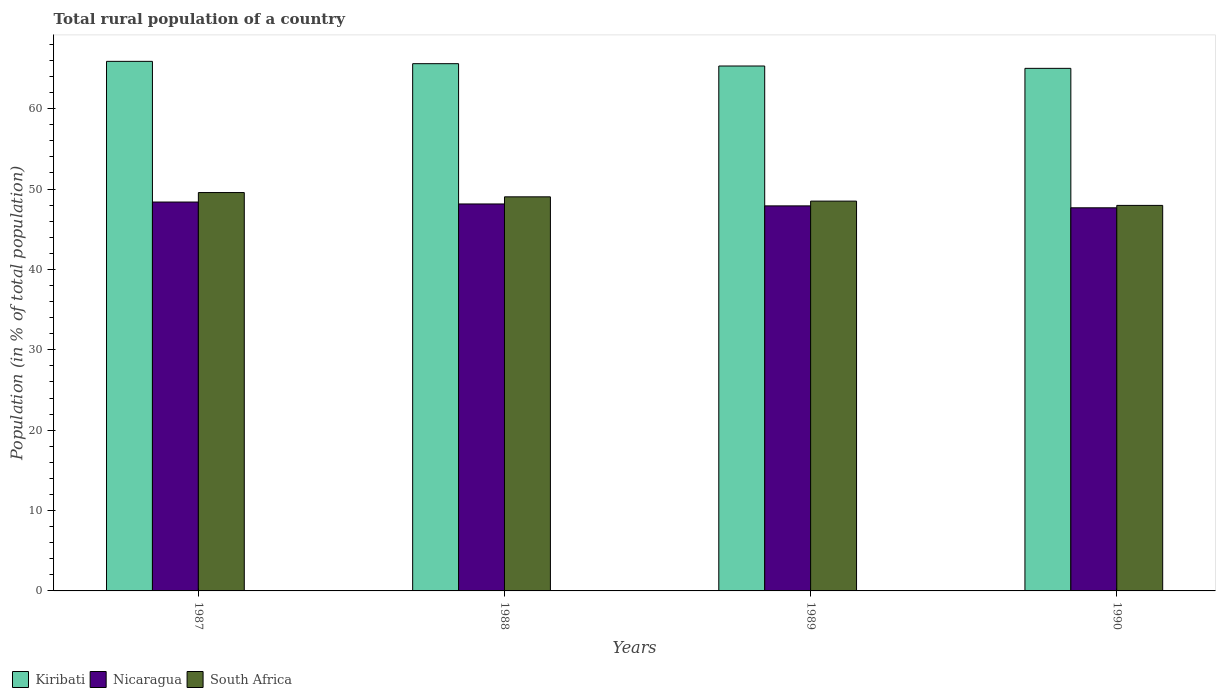How many groups of bars are there?
Keep it short and to the point. 4. Are the number of bars per tick equal to the number of legend labels?
Provide a succinct answer. Yes. Are the number of bars on each tick of the X-axis equal?
Provide a short and direct response. Yes. How many bars are there on the 1st tick from the right?
Your response must be concise. 3. In how many cases, is the number of bars for a given year not equal to the number of legend labels?
Provide a short and direct response. 0. What is the rural population in Kiribati in 1987?
Provide a short and direct response. 65.88. Across all years, what is the maximum rural population in Kiribati?
Keep it short and to the point. 65.88. Across all years, what is the minimum rural population in South Africa?
Ensure brevity in your answer.  47.96. What is the total rural population in Nicaragua in the graph?
Keep it short and to the point. 192.09. What is the difference between the rural population in South Africa in 1987 and that in 1988?
Provide a short and direct response. 0.53. What is the difference between the rural population in Nicaragua in 1987 and the rural population in South Africa in 1989?
Offer a very short reply. -0.11. What is the average rural population in Kiribati per year?
Your answer should be compact. 65.45. In the year 1990, what is the difference between the rural population in Nicaragua and rural population in South Africa?
Your response must be concise. -0.3. What is the ratio of the rural population in South Africa in 1989 to that in 1990?
Give a very brief answer. 1.01. Is the rural population in South Africa in 1989 less than that in 1990?
Offer a very short reply. No. What is the difference between the highest and the second highest rural population in Nicaragua?
Provide a succinct answer. 0.24. What is the difference between the highest and the lowest rural population in Kiribati?
Keep it short and to the point. 0.87. In how many years, is the rural population in South Africa greater than the average rural population in South Africa taken over all years?
Make the answer very short. 2. What does the 1st bar from the left in 1987 represents?
Provide a short and direct response. Kiribati. What does the 3rd bar from the right in 1990 represents?
Keep it short and to the point. Kiribati. Is it the case that in every year, the sum of the rural population in South Africa and rural population in Kiribati is greater than the rural population in Nicaragua?
Offer a very short reply. Yes. How many bars are there?
Keep it short and to the point. 12. How many years are there in the graph?
Provide a short and direct response. 4. Does the graph contain grids?
Your answer should be compact. No. Where does the legend appear in the graph?
Offer a terse response. Bottom left. What is the title of the graph?
Your answer should be compact. Total rural population of a country. What is the label or title of the Y-axis?
Make the answer very short. Population (in % of total population). What is the Population (in % of total population) of Kiribati in 1987?
Provide a short and direct response. 65.88. What is the Population (in % of total population) in Nicaragua in 1987?
Your answer should be compact. 48.38. What is the Population (in % of total population) in South Africa in 1987?
Your response must be concise. 49.56. What is the Population (in % of total population) in Kiribati in 1988?
Your answer should be compact. 65.59. What is the Population (in % of total population) of Nicaragua in 1988?
Your answer should be compact. 48.14. What is the Population (in % of total population) in South Africa in 1988?
Offer a very short reply. 49.03. What is the Population (in % of total population) of Kiribati in 1989?
Ensure brevity in your answer.  65.31. What is the Population (in % of total population) of Nicaragua in 1989?
Make the answer very short. 47.9. What is the Population (in % of total population) of South Africa in 1989?
Your answer should be very brief. 48.49. What is the Population (in % of total population) of Kiribati in 1990?
Your answer should be very brief. 65.01. What is the Population (in % of total population) of Nicaragua in 1990?
Provide a succinct answer. 47.66. What is the Population (in % of total population) of South Africa in 1990?
Give a very brief answer. 47.96. Across all years, what is the maximum Population (in % of total population) of Kiribati?
Your answer should be compact. 65.88. Across all years, what is the maximum Population (in % of total population) in Nicaragua?
Keep it short and to the point. 48.38. Across all years, what is the maximum Population (in % of total population) of South Africa?
Your response must be concise. 49.56. Across all years, what is the minimum Population (in % of total population) in Kiribati?
Provide a succinct answer. 65.01. Across all years, what is the minimum Population (in % of total population) of Nicaragua?
Your answer should be very brief. 47.66. Across all years, what is the minimum Population (in % of total population) in South Africa?
Offer a terse response. 47.96. What is the total Population (in % of total population) in Kiribati in the graph?
Offer a very short reply. 261.8. What is the total Population (in % of total population) of Nicaragua in the graph?
Ensure brevity in your answer.  192.09. What is the total Population (in % of total population) in South Africa in the graph?
Offer a very short reply. 195.05. What is the difference between the Population (in % of total population) in Kiribati in 1987 and that in 1988?
Make the answer very short. 0.29. What is the difference between the Population (in % of total population) in Nicaragua in 1987 and that in 1988?
Offer a terse response. 0.24. What is the difference between the Population (in % of total population) in South Africa in 1987 and that in 1988?
Your answer should be compact. 0.53. What is the difference between the Population (in % of total population) of Kiribati in 1987 and that in 1989?
Ensure brevity in your answer.  0.58. What is the difference between the Population (in % of total population) in Nicaragua in 1987 and that in 1989?
Keep it short and to the point. 0.48. What is the difference between the Population (in % of total population) of South Africa in 1987 and that in 1989?
Make the answer very short. 1.07. What is the difference between the Population (in % of total population) in Kiribati in 1987 and that in 1990?
Provide a short and direct response. 0.87. What is the difference between the Population (in % of total population) in Nicaragua in 1987 and that in 1990?
Offer a very short reply. 0.72. What is the difference between the Population (in % of total population) of South Africa in 1987 and that in 1990?
Keep it short and to the point. 1.6. What is the difference between the Population (in % of total population) of Kiribati in 1988 and that in 1989?
Your answer should be compact. 0.29. What is the difference between the Population (in % of total population) of Nicaragua in 1988 and that in 1989?
Keep it short and to the point. 0.24. What is the difference between the Population (in % of total population) in South Africa in 1988 and that in 1989?
Provide a short and direct response. 0.53. What is the difference between the Population (in % of total population) of Kiribati in 1988 and that in 1990?
Provide a succinct answer. 0.58. What is the difference between the Population (in % of total population) in Nicaragua in 1988 and that in 1990?
Your answer should be compact. 0.48. What is the difference between the Population (in % of total population) in South Africa in 1988 and that in 1990?
Ensure brevity in your answer.  1.06. What is the difference between the Population (in % of total population) in Kiribati in 1989 and that in 1990?
Ensure brevity in your answer.  0.29. What is the difference between the Population (in % of total population) of Nicaragua in 1989 and that in 1990?
Give a very brief answer. 0.24. What is the difference between the Population (in % of total population) in South Africa in 1989 and that in 1990?
Ensure brevity in your answer.  0.53. What is the difference between the Population (in % of total population) of Kiribati in 1987 and the Population (in % of total population) of Nicaragua in 1988?
Your response must be concise. 17.74. What is the difference between the Population (in % of total population) in Kiribati in 1987 and the Population (in % of total population) in South Africa in 1988?
Offer a terse response. 16.86. What is the difference between the Population (in % of total population) of Nicaragua in 1987 and the Population (in % of total population) of South Africa in 1988?
Provide a succinct answer. -0.65. What is the difference between the Population (in % of total population) in Kiribati in 1987 and the Population (in % of total population) in Nicaragua in 1989?
Provide a succinct answer. 17.98. What is the difference between the Population (in % of total population) of Kiribati in 1987 and the Population (in % of total population) of South Africa in 1989?
Provide a succinct answer. 17.39. What is the difference between the Population (in % of total population) in Nicaragua in 1987 and the Population (in % of total population) in South Africa in 1989?
Keep it short and to the point. -0.11. What is the difference between the Population (in % of total population) in Kiribati in 1987 and the Population (in % of total population) in Nicaragua in 1990?
Offer a very short reply. 18.22. What is the difference between the Population (in % of total population) in Kiribati in 1987 and the Population (in % of total population) in South Africa in 1990?
Offer a terse response. 17.92. What is the difference between the Population (in % of total population) in Nicaragua in 1987 and the Population (in % of total population) in South Africa in 1990?
Your response must be concise. 0.42. What is the difference between the Population (in % of total population) of Kiribati in 1988 and the Population (in % of total population) of Nicaragua in 1989?
Give a very brief answer. 17.69. What is the difference between the Population (in % of total population) in Nicaragua in 1988 and the Population (in % of total population) in South Africa in 1989?
Keep it short and to the point. -0.35. What is the difference between the Population (in % of total population) in Kiribati in 1988 and the Population (in % of total population) in Nicaragua in 1990?
Provide a short and direct response. 17.93. What is the difference between the Population (in % of total population) of Kiribati in 1988 and the Population (in % of total population) of South Africa in 1990?
Your response must be concise. 17.63. What is the difference between the Population (in % of total population) in Nicaragua in 1988 and the Population (in % of total population) in South Africa in 1990?
Offer a terse response. 0.18. What is the difference between the Population (in % of total population) in Kiribati in 1989 and the Population (in % of total population) in Nicaragua in 1990?
Your response must be concise. 17.64. What is the difference between the Population (in % of total population) of Kiribati in 1989 and the Population (in % of total population) of South Africa in 1990?
Provide a succinct answer. 17.34. What is the difference between the Population (in % of total population) in Nicaragua in 1989 and the Population (in % of total population) in South Africa in 1990?
Keep it short and to the point. -0.06. What is the average Population (in % of total population) of Kiribati per year?
Your response must be concise. 65.45. What is the average Population (in % of total population) in Nicaragua per year?
Make the answer very short. 48.02. What is the average Population (in % of total population) of South Africa per year?
Your answer should be compact. 48.76. In the year 1987, what is the difference between the Population (in % of total population) of Kiribati and Population (in % of total population) of Nicaragua?
Give a very brief answer. 17.5. In the year 1987, what is the difference between the Population (in % of total population) in Kiribati and Population (in % of total population) in South Africa?
Give a very brief answer. 16.32. In the year 1987, what is the difference between the Population (in % of total population) in Nicaragua and Population (in % of total population) in South Africa?
Give a very brief answer. -1.18. In the year 1988, what is the difference between the Population (in % of total population) in Kiribati and Population (in % of total population) in Nicaragua?
Offer a very short reply. 17.45. In the year 1988, what is the difference between the Population (in % of total population) in Kiribati and Population (in % of total population) in South Africa?
Your answer should be compact. 16.57. In the year 1988, what is the difference between the Population (in % of total population) of Nicaragua and Population (in % of total population) of South Africa?
Provide a succinct answer. -0.89. In the year 1989, what is the difference between the Population (in % of total population) of Kiribati and Population (in % of total population) of Nicaragua?
Give a very brief answer. 17.4. In the year 1989, what is the difference between the Population (in % of total population) of Kiribati and Population (in % of total population) of South Africa?
Ensure brevity in your answer.  16.81. In the year 1989, what is the difference between the Population (in % of total population) of Nicaragua and Population (in % of total population) of South Africa?
Your answer should be compact. -0.59. In the year 1990, what is the difference between the Population (in % of total population) in Kiribati and Population (in % of total population) in Nicaragua?
Give a very brief answer. 17.35. In the year 1990, what is the difference between the Population (in % of total population) in Kiribati and Population (in % of total population) in South Africa?
Offer a terse response. 17.05. In the year 1990, what is the difference between the Population (in % of total population) in Nicaragua and Population (in % of total population) in South Africa?
Provide a succinct answer. -0.3. What is the ratio of the Population (in % of total population) of South Africa in 1987 to that in 1988?
Offer a terse response. 1.01. What is the ratio of the Population (in % of total population) in Kiribati in 1987 to that in 1989?
Your answer should be compact. 1.01. What is the ratio of the Population (in % of total population) of South Africa in 1987 to that in 1989?
Ensure brevity in your answer.  1.02. What is the ratio of the Population (in % of total population) in Kiribati in 1987 to that in 1990?
Your response must be concise. 1.01. What is the ratio of the Population (in % of total population) of Nicaragua in 1987 to that in 1990?
Give a very brief answer. 1.02. What is the ratio of the Population (in % of total population) in Nicaragua in 1988 to that in 1990?
Offer a terse response. 1.01. What is the ratio of the Population (in % of total population) in South Africa in 1988 to that in 1990?
Ensure brevity in your answer.  1.02. What is the ratio of the Population (in % of total population) of Kiribati in 1989 to that in 1990?
Your answer should be compact. 1. What is the ratio of the Population (in % of total population) in South Africa in 1989 to that in 1990?
Your response must be concise. 1.01. What is the difference between the highest and the second highest Population (in % of total population) of Kiribati?
Offer a very short reply. 0.29. What is the difference between the highest and the second highest Population (in % of total population) in Nicaragua?
Ensure brevity in your answer.  0.24. What is the difference between the highest and the second highest Population (in % of total population) of South Africa?
Make the answer very short. 0.53. What is the difference between the highest and the lowest Population (in % of total population) in Kiribati?
Your answer should be compact. 0.87. What is the difference between the highest and the lowest Population (in % of total population) in Nicaragua?
Your answer should be very brief. 0.72. What is the difference between the highest and the lowest Population (in % of total population) of South Africa?
Your answer should be very brief. 1.6. 